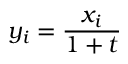Convert formula to latex. <formula><loc_0><loc_0><loc_500><loc_500>y _ { i } = { \frac { x _ { i } } { 1 + t } }</formula> 